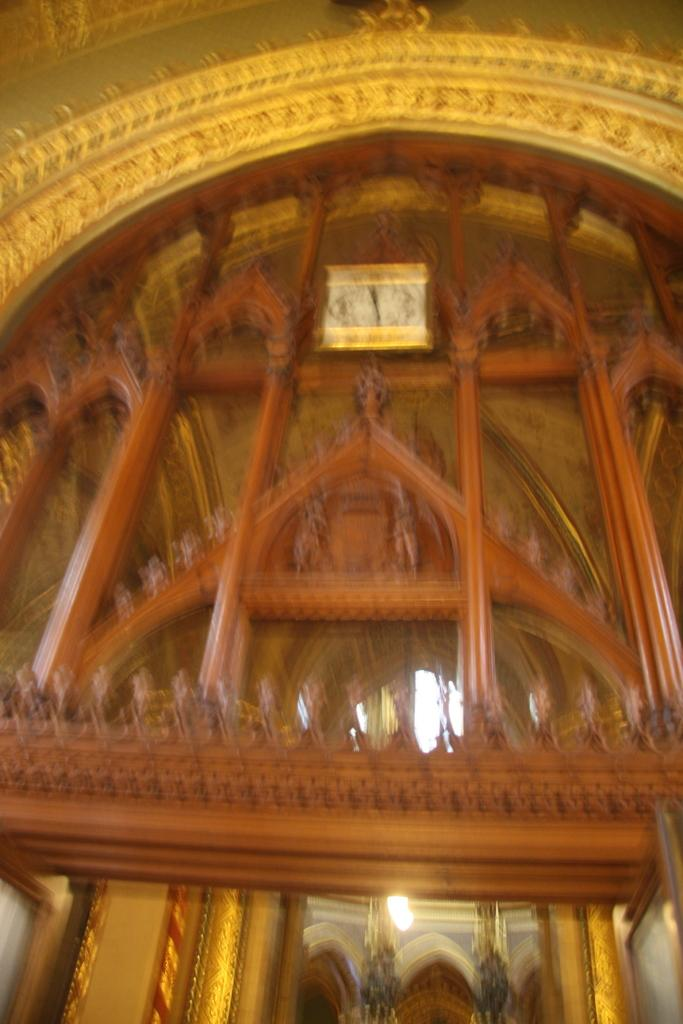What type of location is depicted in the image? The image shows the inside of a building. What lighting fixtures can be seen in the image? There are lamps in the image. Is there any time-related object in the image? Yes, there is a clock in the image. How does the farmer tend to the crops inside the building in the image? There is no farmer or crops present in the image; it shows the inside of a building with lamps and a clock. 